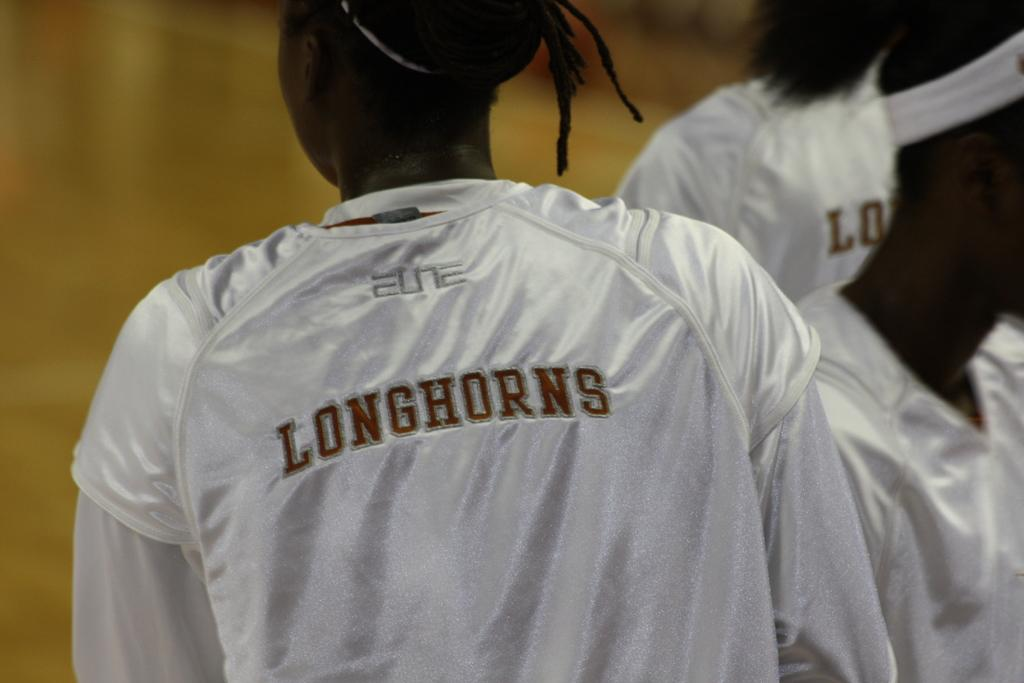<image>
Write a terse but informative summary of the picture. Several African American girls are wearing white jersey's with their team name, Longhorns, on the back. 